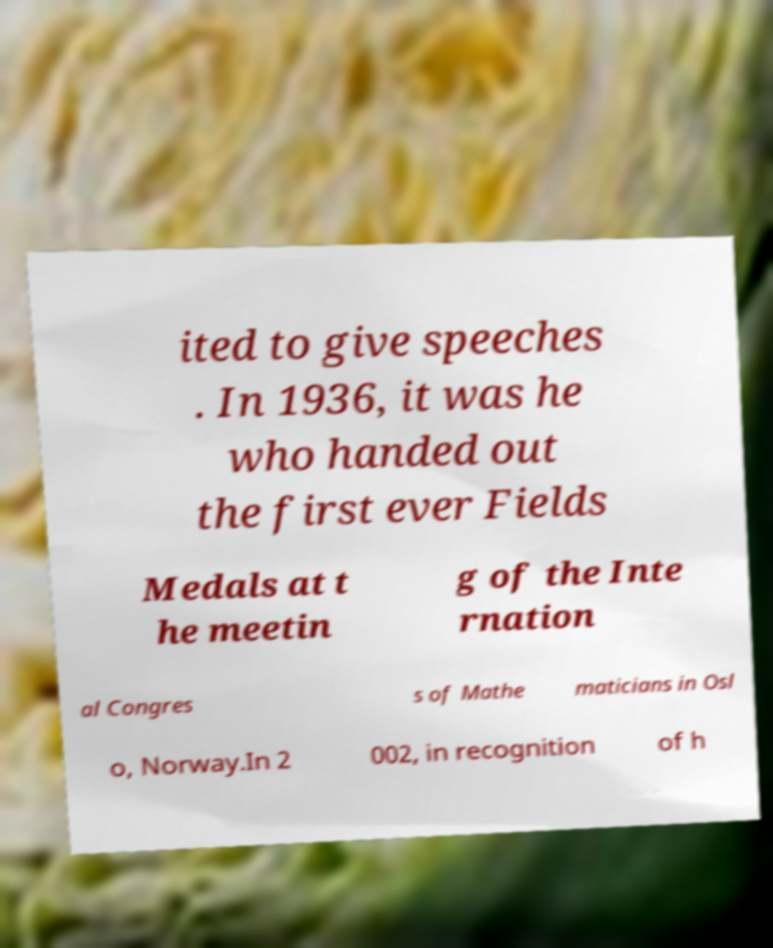There's text embedded in this image that I need extracted. Can you transcribe it verbatim? ited to give speeches . In 1936, it was he who handed out the first ever Fields Medals at t he meetin g of the Inte rnation al Congres s of Mathe maticians in Osl o, Norway.In 2 002, in recognition of h 